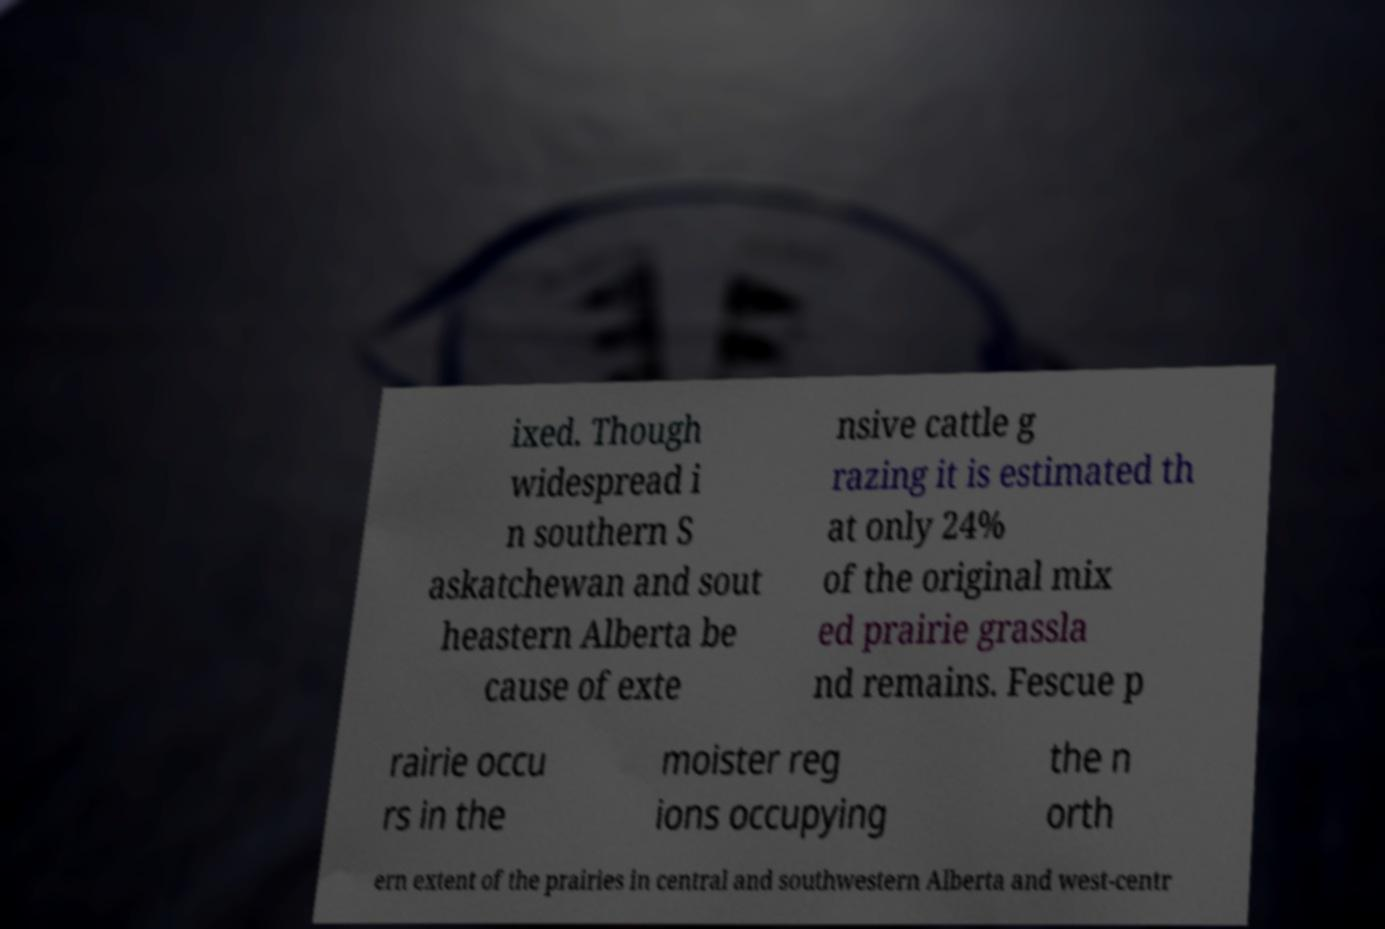Could you assist in decoding the text presented in this image and type it out clearly? ixed. Though widespread i n southern S askatchewan and sout heastern Alberta be cause of exte nsive cattle g razing it is estimated th at only 24% of the original mix ed prairie grassla nd remains. Fescue p rairie occu rs in the moister reg ions occupying the n orth ern extent of the prairies in central and southwestern Alberta and west-centr 